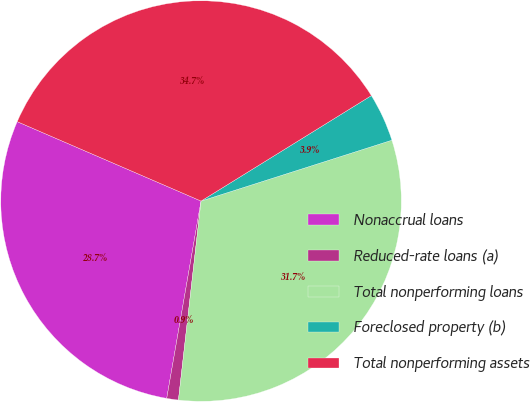<chart> <loc_0><loc_0><loc_500><loc_500><pie_chart><fcel>Nonaccrual loans<fcel>Reduced-rate loans (a)<fcel>Total nonperforming loans<fcel>Foreclosed property (b)<fcel>Total nonperforming assets<nl><fcel>28.75%<fcel>0.94%<fcel>31.72%<fcel>3.91%<fcel>34.69%<nl></chart> 